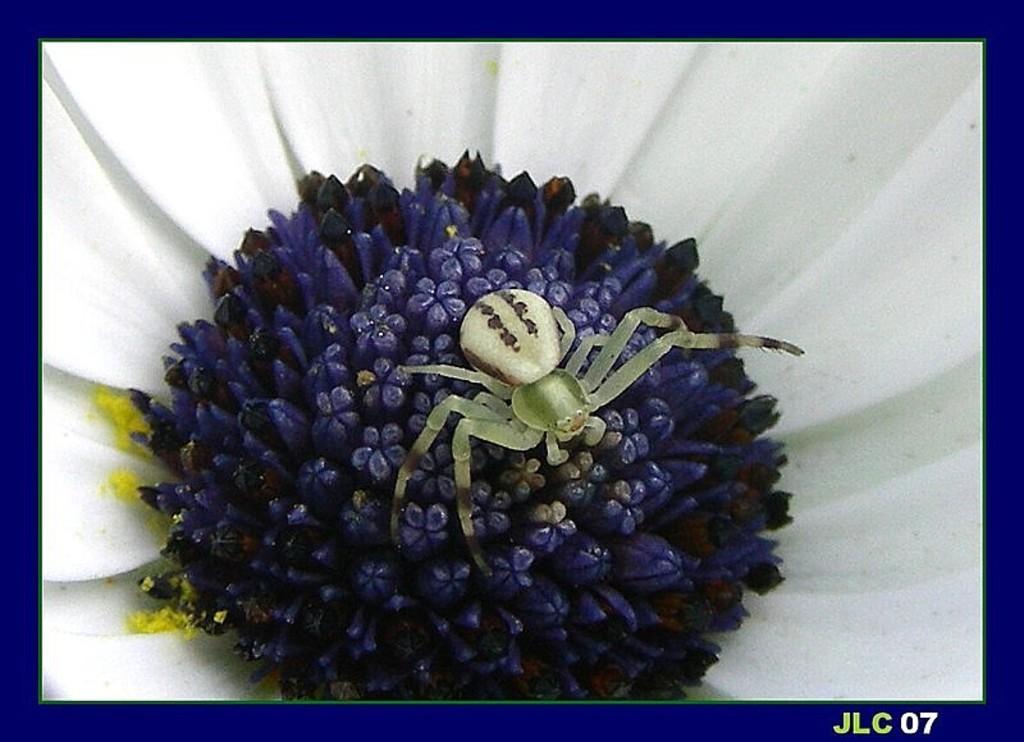Please provide a concise description of this image. In this picture, we see the flower and an insect in white color is sucking the honey from the flower. This flower is in white and blue color. This might be an edited image or it might be a photo frame. 